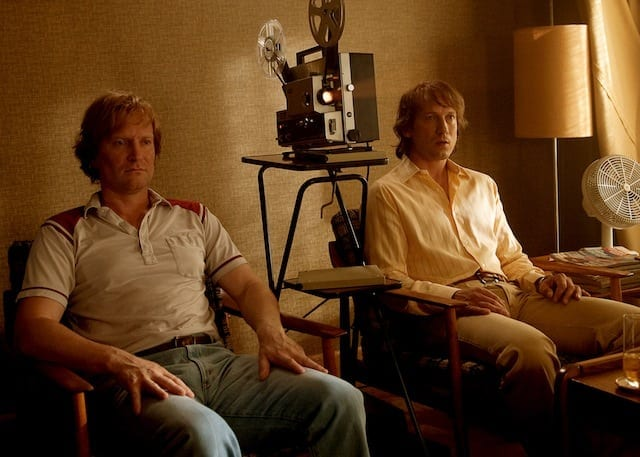Describe a realistic scenario where the presence of the vintage projector is significant to the image. In a small-town film club meeting, two enthusiasts, John and Peter, gather every Thursday evening to watch classic movies projected from John's vintage film projector. The projector, a cherished heirloom from John's grandfather, represents not just a device but a bridge to the golden age of cinema. Each film screening is an event filled with anticipation and excitement, drawing memories of times past and sparking conversations that extend late into the night.  Describe a short, realistic scenario involving the setting and people in the image. Two friends catch up in a cozy home office, discussing their favorite films and reliving old memories. The yellowing wallpaper and aged furniture add a nostalgic touch to the room. The film projector between them is a conversation starter and a cherished piece of history. 